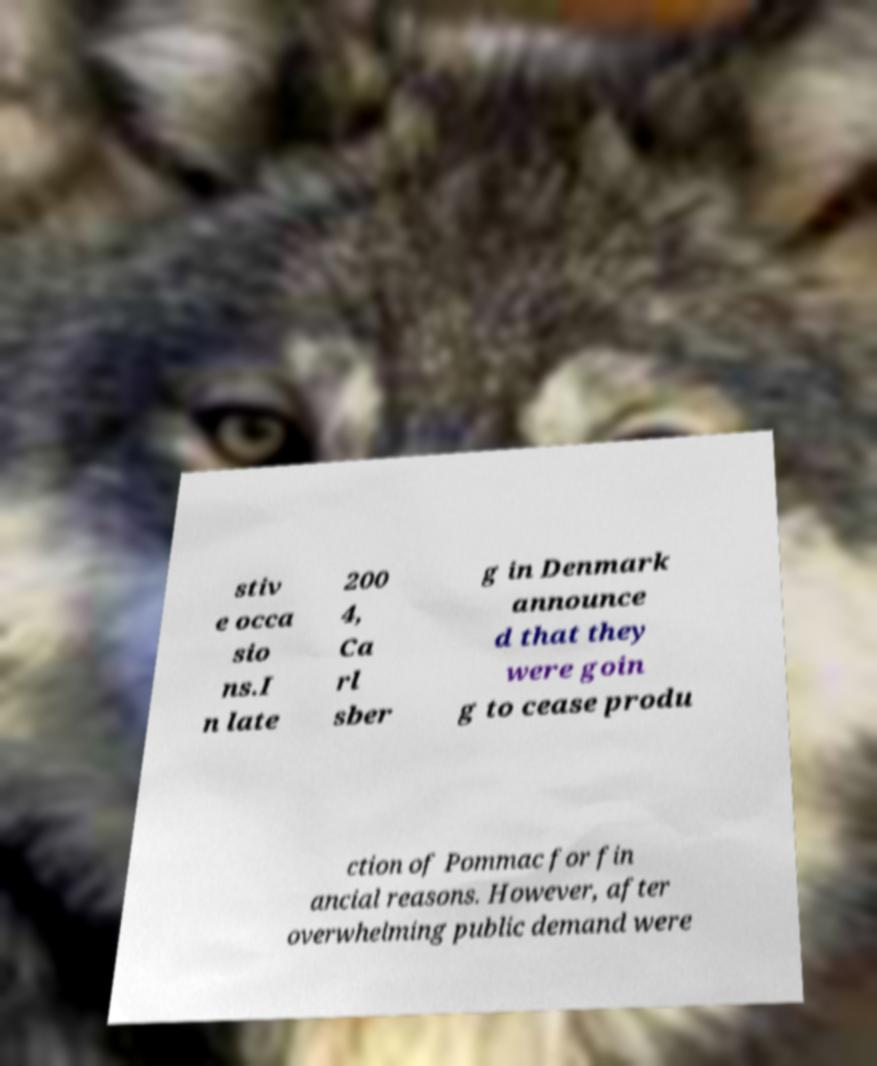Please identify and transcribe the text found in this image. stiv e occa sio ns.I n late 200 4, Ca rl sber g in Denmark announce d that they were goin g to cease produ ction of Pommac for fin ancial reasons. However, after overwhelming public demand were 